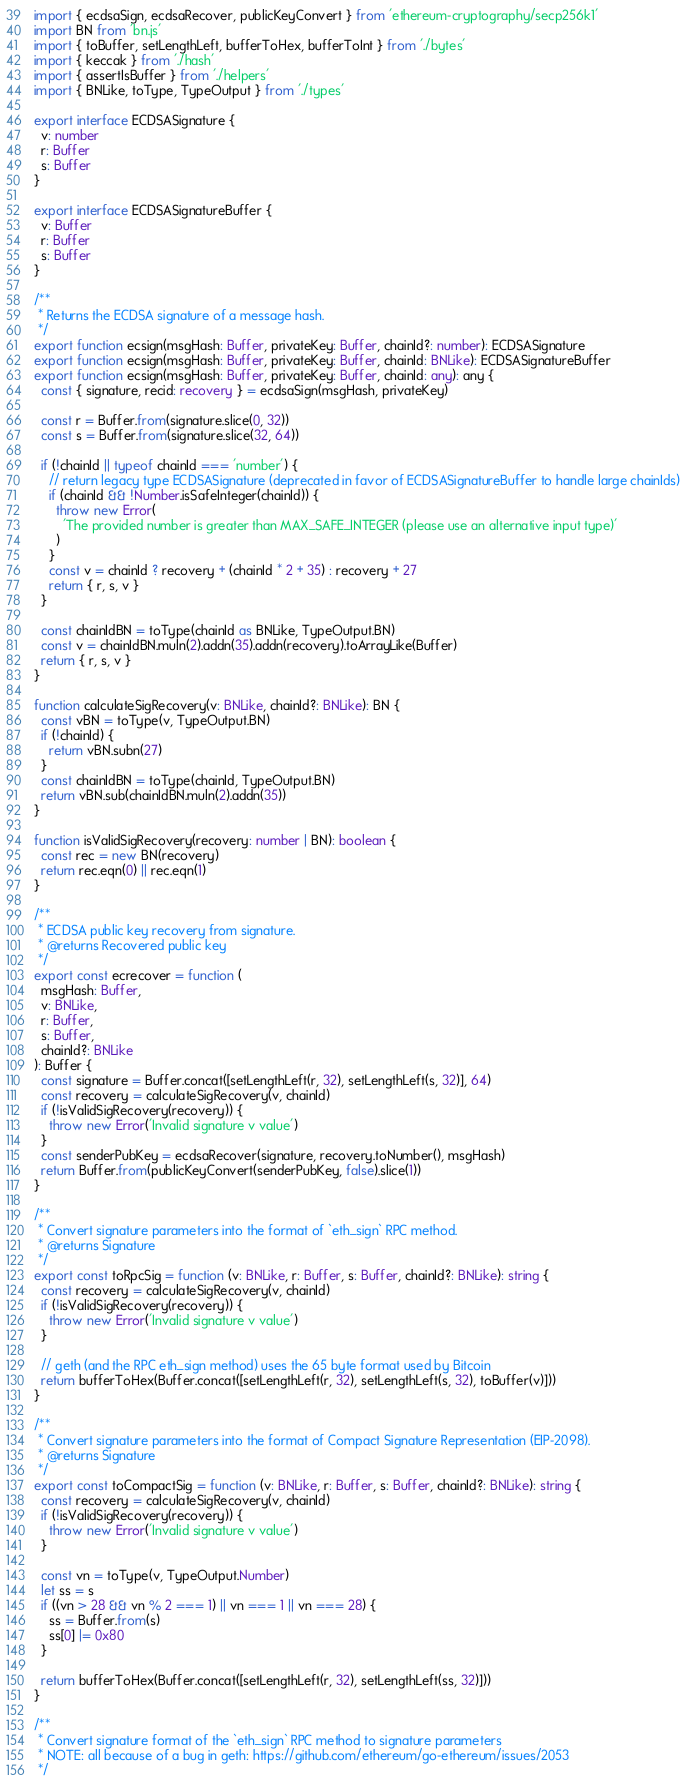Convert code to text. <code><loc_0><loc_0><loc_500><loc_500><_TypeScript_>import { ecdsaSign, ecdsaRecover, publicKeyConvert } from 'ethereum-cryptography/secp256k1'
import BN from 'bn.js'
import { toBuffer, setLengthLeft, bufferToHex, bufferToInt } from './bytes'
import { keccak } from './hash'
import { assertIsBuffer } from './helpers'
import { BNLike, toType, TypeOutput } from './types'

export interface ECDSASignature {
  v: number
  r: Buffer
  s: Buffer
}

export interface ECDSASignatureBuffer {
  v: Buffer
  r: Buffer
  s: Buffer
}

/**
 * Returns the ECDSA signature of a message hash.
 */
export function ecsign(msgHash: Buffer, privateKey: Buffer, chainId?: number): ECDSASignature
export function ecsign(msgHash: Buffer, privateKey: Buffer, chainId: BNLike): ECDSASignatureBuffer
export function ecsign(msgHash: Buffer, privateKey: Buffer, chainId: any): any {
  const { signature, recid: recovery } = ecdsaSign(msgHash, privateKey)

  const r = Buffer.from(signature.slice(0, 32))
  const s = Buffer.from(signature.slice(32, 64))

  if (!chainId || typeof chainId === 'number') {
    // return legacy type ECDSASignature (deprecated in favor of ECDSASignatureBuffer to handle large chainIds)
    if (chainId && !Number.isSafeInteger(chainId)) {
      throw new Error(
        'The provided number is greater than MAX_SAFE_INTEGER (please use an alternative input type)'
      )
    }
    const v = chainId ? recovery + (chainId * 2 + 35) : recovery + 27
    return { r, s, v }
  }

  const chainIdBN = toType(chainId as BNLike, TypeOutput.BN)
  const v = chainIdBN.muln(2).addn(35).addn(recovery).toArrayLike(Buffer)
  return { r, s, v }
}

function calculateSigRecovery(v: BNLike, chainId?: BNLike): BN {
  const vBN = toType(v, TypeOutput.BN)
  if (!chainId) {
    return vBN.subn(27)
  }
  const chainIdBN = toType(chainId, TypeOutput.BN)
  return vBN.sub(chainIdBN.muln(2).addn(35))
}

function isValidSigRecovery(recovery: number | BN): boolean {
  const rec = new BN(recovery)
  return rec.eqn(0) || rec.eqn(1)
}

/**
 * ECDSA public key recovery from signature.
 * @returns Recovered public key
 */
export const ecrecover = function (
  msgHash: Buffer,
  v: BNLike,
  r: Buffer,
  s: Buffer,
  chainId?: BNLike
): Buffer {
  const signature = Buffer.concat([setLengthLeft(r, 32), setLengthLeft(s, 32)], 64)
  const recovery = calculateSigRecovery(v, chainId)
  if (!isValidSigRecovery(recovery)) {
    throw new Error('Invalid signature v value')
  }
  const senderPubKey = ecdsaRecover(signature, recovery.toNumber(), msgHash)
  return Buffer.from(publicKeyConvert(senderPubKey, false).slice(1))
}

/**
 * Convert signature parameters into the format of `eth_sign` RPC method.
 * @returns Signature
 */
export const toRpcSig = function (v: BNLike, r: Buffer, s: Buffer, chainId?: BNLike): string {
  const recovery = calculateSigRecovery(v, chainId)
  if (!isValidSigRecovery(recovery)) {
    throw new Error('Invalid signature v value')
  }

  // geth (and the RPC eth_sign method) uses the 65 byte format used by Bitcoin
  return bufferToHex(Buffer.concat([setLengthLeft(r, 32), setLengthLeft(s, 32), toBuffer(v)]))
}

/**
 * Convert signature parameters into the format of Compact Signature Representation (EIP-2098).
 * @returns Signature
 */
export const toCompactSig = function (v: BNLike, r: Buffer, s: Buffer, chainId?: BNLike): string {
  const recovery = calculateSigRecovery(v, chainId)
  if (!isValidSigRecovery(recovery)) {
    throw new Error('Invalid signature v value')
  }

  const vn = toType(v, TypeOutput.Number)
  let ss = s
  if ((vn > 28 && vn % 2 === 1) || vn === 1 || vn === 28) {
    ss = Buffer.from(s)
    ss[0] |= 0x80
  }

  return bufferToHex(Buffer.concat([setLengthLeft(r, 32), setLengthLeft(ss, 32)]))
}

/**
 * Convert signature format of the `eth_sign` RPC method to signature parameters
 * NOTE: all because of a bug in geth: https://github.com/ethereum/go-ethereum/issues/2053
 */</code> 